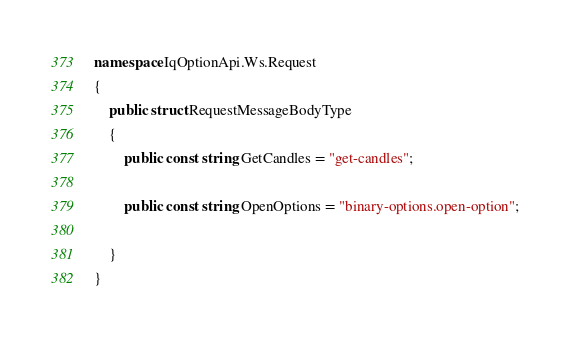Convert code to text. <code><loc_0><loc_0><loc_500><loc_500><_C#_>namespace IqOptionApi.Ws.Request
{
    public struct RequestMessageBodyType
    {
        public const string GetCandles = "get-candles";

        public const string OpenOptions = "binary-options.open-option";

    }
}</code> 